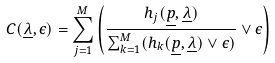<formula> <loc_0><loc_0><loc_500><loc_500>C ( \underline { \lambda } , \epsilon ) = \sum _ { j = 1 } ^ { M } \left ( \frac { h _ { j } ( \underline { p } , \underline { \lambda } ) } { \sum _ { k = 1 } ^ { M } ( h _ { k } ( \underline { p } , \underline { \lambda } ) \vee \epsilon ) } \vee \epsilon \right )</formula> 